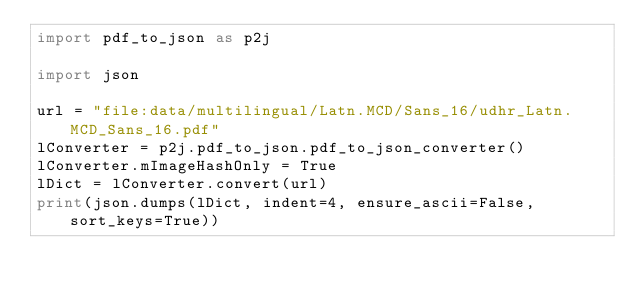<code> <loc_0><loc_0><loc_500><loc_500><_Python_>import pdf_to_json as p2j

import json

url = "file:data/multilingual/Latn.MCD/Sans_16/udhr_Latn.MCD_Sans_16.pdf"
lConverter = p2j.pdf_to_json.pdf_to_json_converter()
lConverter.mImageHashOnly = True
lDict = lConverter.convert(url)
print(json.dumps(lDict, indent=4, ensure_ascii=False, sort_keys=True))
</code> 